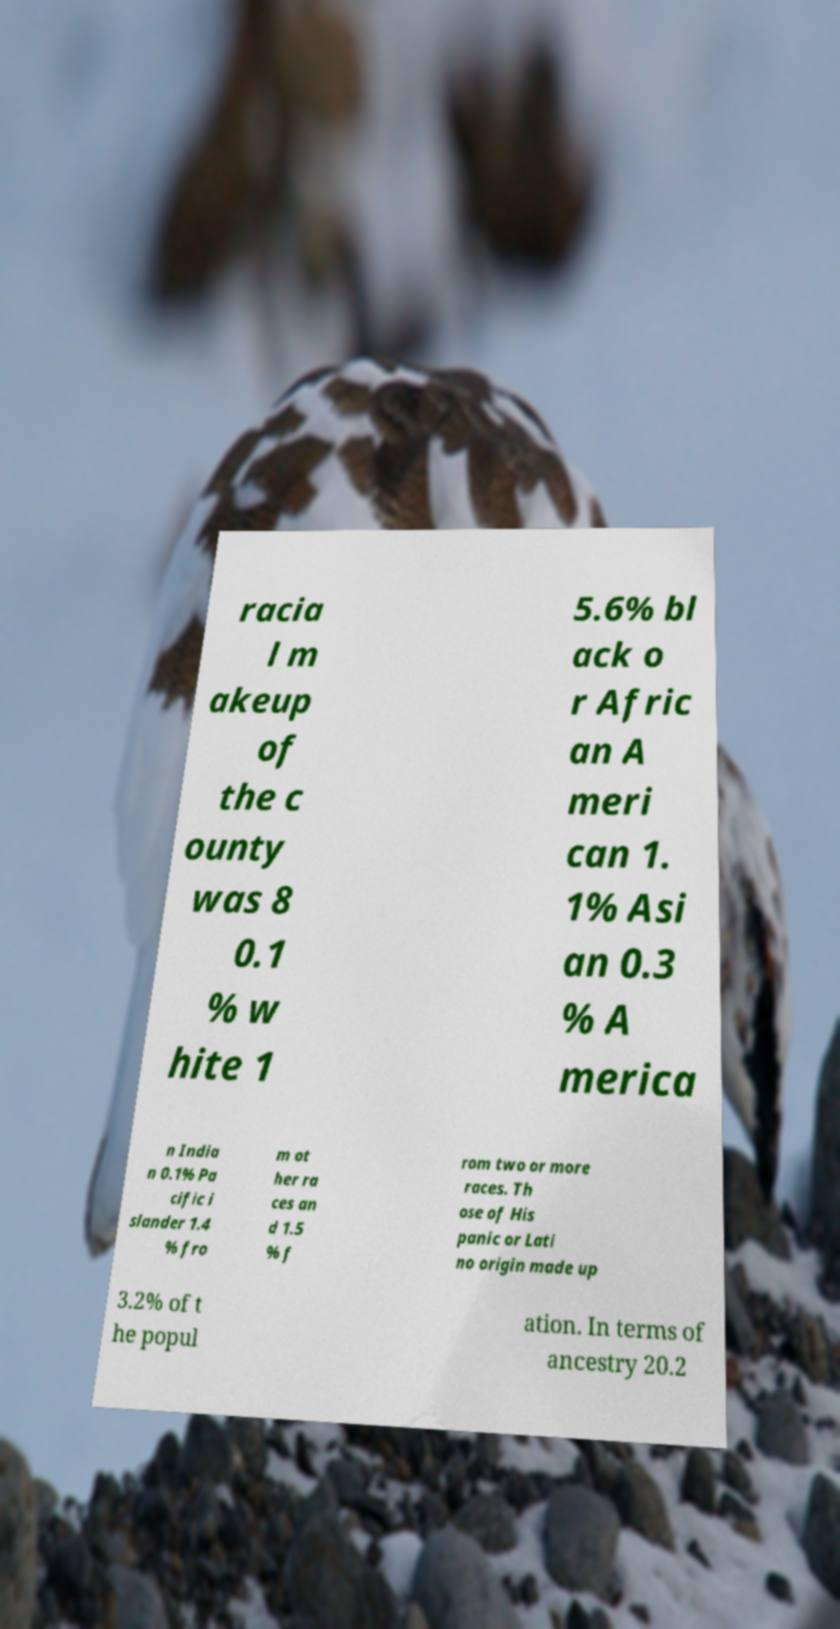Can you accurately transcribe the text from the provided image for me? racia l m akeup of the c ounty was 8 0.1 % w hite 1 5.6% bl ack o r Afric an A meri can 1. 1% Asi an 0.3 % A merica n India n 0.1% Pa cific i slander 1.4 % fro m ot her ra ces an d 1.5 % f rom two or more races. Th ose of His panic or Lati no origin made up 3.2% of t he popul ation. In terms of ancestry 20.2 